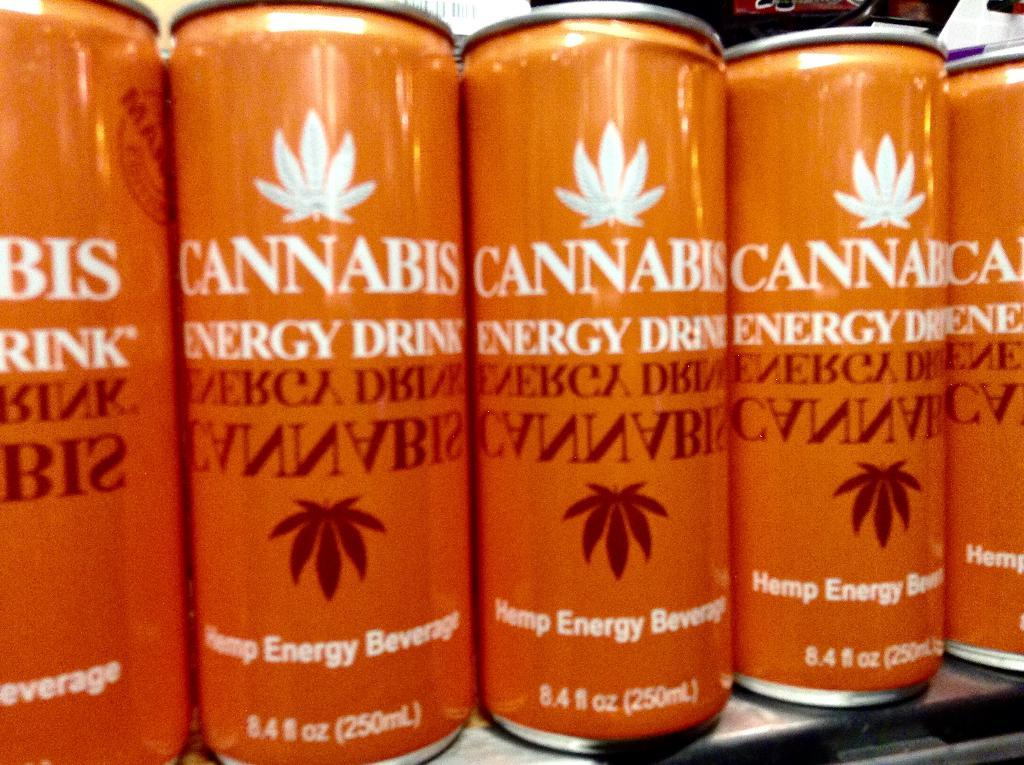<image>
Share a concise interpretation of the image provided. A row of cannabis energy drinks are lined up on a shelf. 